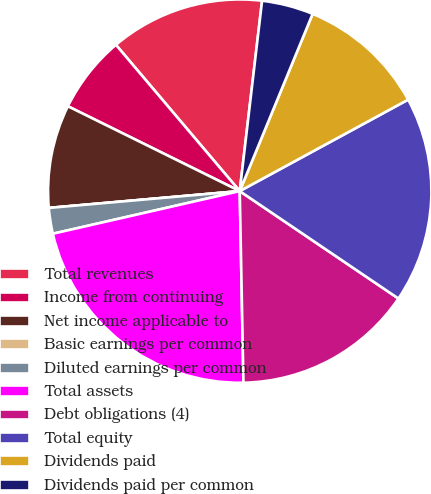Convert chart. <chart><loc_0><loc_0><loc_500><loc_500><pie_chart><fcel>Total revenues<fcel>Income from continuing<fcel>Net income applicable to<fcel>Basic earnings per common<fcel>Diluted earnings per common<fcel>Total assets<fcel>Debt obligations (4)<fcel>Total equity<fcel>Dividends paid<fcel>Dividends paid per common<nl><fcel>13.04%<fcel>6.52%<fcel>8.7%<fcel>0.0%<fcel>2.17%<fcel>21.74%<fcel>15.22%<fcel>17.39%<fcel>10.87%<fcel>4.35%<nl></chart> 